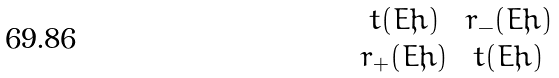<formula> <loc_0><loc_0><loc_500><loc_500>\begin{matrix} t ( E ; \hbar { ) } & r _ { - } ( E ; \hbar { ) } \\ r _ { + } ( E ; \hbar { ) } & t ( E ; \hbar { ) } \end{matrix}</formula> 